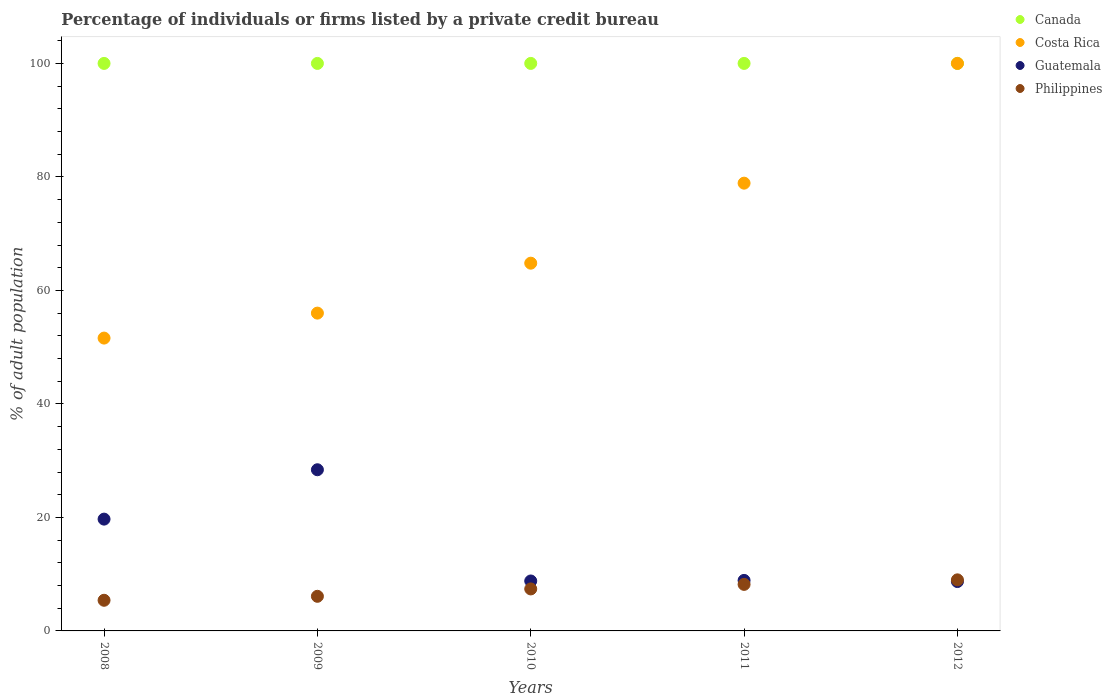What is the percentage of population listed by a private credit bureau in Canada in 2012?
Your answer should be very brief. 100. What is the total percentage of population listed by a private credit bureau in Guatemala in the graph?
Make the answer very short. 74.5. What is the difference between the percentage of population listed by a private credit bureau in Guatemala in 2011 and the percentage of population listed by a private credit bureau in Costa Rica in 2009?
Keep it short and to the point. -47.1. What is the average percentage of population listed by a private credit bureau in Philippines per year?
Give a very brief answer. 7.22. In the year 2011, what is the difference between the percentage of population listed by a private credit bureau in Costa Rica and percentage of population listed by a private credit bureau in Canada?
Provide a short and direct response. -21.1. In how many years, is the percentage of population listed by a private credit bureau in Costa Rica greater than 76 %?
Provide a short and direct response. 2. Is the percentage of population listed by a private credit bureau in Canada in 2008 less than that in 2011?
Your answer should be compact. No. Is the difference between the percentage of population listed by a private credit bureau in Costa Rica in 2008 and 2009 greater than the difference between the percentage of population listed by a private credit bureau in Canada in 2008 and 2009?
Your response must be concise. No. What is the difference between the highest and the second highest percentage of population listed by a private credit bureau in Costa Rica?
Give a very brief answer. 21.1. What is the difference between the highest and the lowest percentage of population listed by a private credit bureau in Costa Rica?
Offer a very short reply. 48.4. Is the sum of the percentage of population listed by a private credit bureau in Costa Rica in 2009 and 2012 greater than the maximum percentage of population listed by a private credit bureau in Guatemala across all years?
Give a very brief answer. Yes. Is it the case that in every year, the sum of the percentage of population listed by a private credit bureau in Costa Rica and percentage of population listed by a private credit bureau in Guatemala  is greater than the percentage of population listed by a private credit bureau in Philippines?
Provide a succinct answer. Yes. Does the percentage of population listed by a private credit bureau in Costa Rica monotonically increase over the years?
Keep it short and to the point. Yes. Is the percentage of population listed by a private credit bureau in Canada strictly greater than the percentage of population listed by a private credit bureau in Philippines over the years?
Provide a succinct answer. Yes. What is the difference between two consecutive major ticks on the Y-axis?
Provide a succinct answer. 20. Are the values on the major ticks of Y-axis written in scientific E-notation?
Your answer should be very brief. No. Does the graph contain grids?
Give a very brief answer. No. What is the title of the graph?
Offer a very short reply. Percentage of individuals or firms listed by a private credit bureau. What is the label or title of the X-axis?
Provide a short and direct response. Years. What is the label or title of the Y-axis?
Offer a terse response. % of adult population. What is the % of adult population in Costa Rica in 2008?
Provide a short and direct response. 51.6. What is the % of adult population in Guatemala in 2008?
Offer a terse response. 19.7. What is the % of adult population in Canada in 2009?
Your answer should be compact. 100. What is the % of adult population of Guatemala in 2009?
Make the answer very short. 28.4. What is the % of adult population of Philippines in 2009?
Give a very brief answer. 6.1. What is the % of adult population in Costa Rica in 2010?
Offer a terse response. 64.8. What is the % of adult population of Costa Rica in 2011?
Give a very brief answer. 78.9. What is the % of adult population in Canada in 2012?
Give a very brief answer. 100. What is the % of adult population of Guatemala in 2012?
Provide a succinct answer. 8.7. Across all years, what is the maximum % of adult population in Canada?
Offer a very short reply. 100. Across all years, what is the maximum % of adult population in Guatemala?
Offer a terse response. 28.4. Across all years, what is the maximum % of adult population in Philippines?
Your response must be concise. 9. Across all years, what is the minimum % of adult population of Costa Rica?
Your answer should be very brief. 51.6. Across all years, what is the minimum % of adult population in Philippines?
Provide a succinct answer. 5.4. What is the total % of adult population in Costa Rica in the graph?
Give a very brief answer. 351.3. What is the total % of adult population in Guatemala in the graph?
Offer a terse response. 74.5. What is the total % of adult population in Philippines in the graph?
Your answer should be compact. 36.1. What is the difference between the % of adult population of Canada in 2008 and that in 2010?
Give a very brief answer. 0. What is the difference between the % of adult population of Costa Rica in 2008 and that in 2010?
Offer a terse response. -13.2. What is the difference between the % of adult population in Philippines in 2008 and that in 2010?
Make the answer very short. -2. What is the difference between the % of adult population of Costa Rica in 2008 and that in 2011?
Provide a succinct answer. -27.3. What is the difference between the % of adult population of Canada in 2008 and that in 2012?
Your response must be concise. 0. What is the difference between the % of adult population of Costa Rica in 2008 and that in 2012?
Offer a terse response. -48.4. What is the difference between the % of adult population of Guatemala in 2008 and that in 2012?
Offer a terse response. 11. What is the difference between the % of adult population in Canada in 2009 and that in 2010?
Provide a succinct answer. 0. What is the difference between the % of adult population in Costa Rica in 2009 and that in 2010?
Make the answer very short. -8.8. What is the difference between the % of adult population of Guatemala in 2009 and that in 2010?
Your answer should be very brief. 19.6. What is the difference between the % of adult population of Philippines in 2009 and that in 2010?
Your response must be concise. -1.3. What is the difference between the % of adult population in Canada in 2009 and that in 2011?
Provide a short and direct response. 0. What is the difference between the % of adult population in Costa Rica in 2009 and that in 2011?
Your response must be concise. -22.9. What is the difference between the % of adult population in Guatemala in 2009 and that in 2011?
Provide a succinct answer. 19.5. What is the difference between the % of adult population of Canada in 2009 and that in 2012?
Provide a succinct answer. 0. What is the difference between the % of adult population in Costa Rica in 2009 and that in 2012?
Your response must be concise. -44. What is the difference between the % of adult population of Canada in 2010 and that in 2011?
Keep it short and to the point. 0. What is the difference between the % of adult population of Costa Rica in 2010 and that in 2011?
Keep it short and to the point. -14.1. What is the difference between the % of adult population in Philippines in 2010 and that in 2011?
Offer a very short reply. -0.8. What is the difference between the % of adult population in Canada in 2010 and that in 2012?
Your answer should be very brief. 0. What is the difference between the % of adult population of Costa Rica in 2010 and that in 2012?
Your response must be concise. -35.2. What is the difference between the % of adult population in Canada in 2011 and that in 2012?
Ensure brevity in your answer.  0. What is the difference between the % of adult population of Costa Rica in 2011 and that in 2012?
Your answer should be very brief. -21.1. What is the difference between the % of adult population in Guatemala in 2011 and that in 2012?
Keep it short and to the point. 0.2. What is the difference between the % of adult population of Canada in 2008 and the % of adult population of Guatemala in 2009?
Offer a terse response. 71.6. What is the difference between the % of adult population of Canada in 2008 and the % of adult population of Philippines in 2009?
Ensure brevity in your answer.  93.9. What is the difference between the % of adult population of Costa Rica in 2008 and the % of adult population of Guatemala in 2009?
Your answer should be very brief. 23.2. What is the difference between the % of adult population in Costa Rica in 2008 and the % of adult population in Philippines in 2009?
Provide a short and direct response. 45.5. What is the difference between the % of adult population in Canada in 2008 and the % of adult population in Costa Rica in 2010?
Give a very brief answer. 35.2. What is the difference between the % of adult population in Canada in 2008 and the % of adult population in Guatemala in 2010?
Your response must be concise. 91.2. What is the difference between the % of adult population in Canada in 2008 and the % of adult population in Philippines in 2010?
Make the answer very short. 92.6. What is the difference between the % of adult population in Costa Rica in 2008 and the % of adult population in Guatemala in 2010?
Offer a terse response. 42.8. What is the difference between the % of adult population in Costa Rica in 2008 and the % of adult population in Philippines in 2010?
Keep it short and to the point. 44.2. What is the difference between the % of adult population of Canada in 2008 and the % of adult population of Costa Rica in 2011?
Offer a terse response. 21.1. What is the difference between the % of adult population in Canada in 2008 and the % of adult population in Guatemala in 2011?
Ensure brevity in your answer.  91.1. What is the difference between the % of adult population of Canada in 2008 and the % of adult population of Philippines in 2011?
Keep it short and to the point. 91.8. What is the difference between the % of adult population of Costa Rica in 2008 and the % of adult population of Guatemala in 2011?
Give a very brief answer. 42.7. What is the difference between the % of adult population of Costa Rica in 2008 and the % of adult population of Philippines in 2011?
Ensure brevity in your answer.  43.4. What is the difference between the % of adult population of Canada in 2008 and the % of adult population of Guatemala in 2012?
Offer a terse response. 91.3. What is the difference between the % of adult population of Canada in 2008 and the % of adult population of Philippines in 2012?
Your answer should be compact. 91. What is the difference between the % of adult population of Costa Rica in 2008 and the % of adult population of Guatemala in 2012?
Your response must be concise. 42.9. What is the difference between the % of adult population in Costa Rica in 2008 and the % of adult population in Philippines in 2012?
Provide a succinct answer. 42.6. What is the difference between the % of adult population in Guatemala in 2008 and the % of adult population in Philippines in 2012?
Offer a very short reply. 10.7. What is the difference between the % of adult population of Canada in 2009 and the % of adult population of Costa Rica in 2010?
Your answer should be compact. 35.2. What is the difference between the % of adult population of Canada in 2009 and the % of adult population of Guatemala in 2010?
Ensure brevity in your answer.  91.2. What is the difference between the % of adult population of Canada in 2009 and the % of adult population of Philippines in 2010?
Keep it short and to the point. 92.6. What is the difference between the % of adult population of Costa Rica in 2009 and the % of adult population of Guatemala in 2010?
Your answer should be compact. 47.2. What is the difference between the % of adult population of Costa Rica in 2009 and the % of adult population of Philippines in 2010?
Your answer should be very brief. 48.6. What is the difference between the % of adult population of Canada in 2009 and the % of adult population of Costa Rica in 2011?
Offer a very short reply. 21.1. What is the difference between the % of adult population of Canada in 2009 and the % of adult population of Guatemala in 2011?
Your answer should be compact. 91.1. What is the difference between the % of adult population of Canada in 2009 and the % of adult population of Philippines in 2011?
Provide a short and direct response. 91.8. What is the difference between the % of adult population of Costa Rica in 2009 and the % of adult population of Guatemala in 2011?
Your answer should be compact. 47.1. What is the difference between the % of adult population in Costa Rica in 2009 and the % of adult population in Philippines in 2011?
Offer a very short reply. 47.8. What is the difference between the % of adult population of Guatemala in 2009 and the % of adult population of Philippines in 2011?
Your response must be concise. 20.2. What is the difference between the % of adult population in Canada in 2009 and the % of adult population in Guatemala in 2012?
Offer a very short reply. 91.3. What is the difference between the % of adult population in Canada in 2009 and the % of adult population in Philippines in 2012?
Give a very brief answer. 91. What is the difference between the % of adult population of Costa Rica in 2009 and the % of adult population of Guatemala in 2012?
Offer a very short reply. 47.3. What is the difference between the % of adult population of Canada in 2010 and the % of adult population of Costa Rica in 2011?
Make the answer very short. 21.1. What is the difference between the % of adult population in Canada in 2010 and the % of adult population in Guatemala in 2011?
Provide a succinct answer. 91.1. What is the difference between the % of adult population of Canada in 2010 and the % of adult population of Philippines in 2011?
Keep it short and to the point. 91.8. What is the difference between the % of adult population in Costa Rica in 2010 and the % of adult population in Guatemala in 2011?
Your response must be concise. 55.9. What is the difference between the % of adult population in Costa Rica in 2010 and the % of adult population in Philippines in 2011?
Give a very brief answer. 56.6. What is the difference between the % of adult population of Canada in 2010 and the % of adult population of Costa Rica in 2012?
Give a very brief answer. 0. What is the difference between the % of adult population of Canada in 2010 and the % of adult population of Guatemala in 2012?
Your response must be concise. 91.3. What is the difference between the % of adult population in Canada in 2010 and the % of adult population in Philippines in 2012?
Give a very brief answer. 91. What is the difference between the % of adult population of Costa Rica in 2010 and the % of adult population of Guatemala in 2012?
Make the answer very short. 56.1. What is the difference between the % of adult population of Costa Rica in 2010 and the % of adult population of Philippines in 2012?
Offer a terse response. 55.8. What is the difference between the % of adult population in Guatemala in 2010 and the % of adult population in Philippines in 2012?
Offer a very short reply. -0.2. What is the difference between the % of adult population in Canada in 2011 and the % of adult population in Guatemala in 2012?
Your response must be concise. 91.3. What is the difference between the % of adult population in Canada in 2011 and the % of adult population in Philippines in 2012?
Make the answer very short. 91. What is the difference between the % of adult population in Costa Rica in 2011 and the % of adult population in Guatemala in 2012?
Ensure brevity in your answer.  70.2. What is the difference between the % of adult population of Costa Rica in 2011 and the % of adult population of Philippines in 2012?
Offer a terse response. 69.9. What is the difference between the % of adult population in Guatemala in 2011 and the % of adult population in Philippines in 2012?
Your response must be concise. -0.1. What is the average % of adult population of Costa Rica per year?
Make the answer very short. 70.26. What is the average % of adult population in Guatemala per year?
Keep it short and to the point. 14.9. What is the average % of adult population of Philippines per year?
Keep it short and to the point. 7.22. In the year 2008, what is the difference between the % of adult population of Canada and % of adult population of Costa Rica?
Give a very brief answer. 48.4. In the year 2008, what is the difference between the % of adult population in Canada and % of adult population in Guatemala?
Give a very brief answer. 80.3. In the year 2008, what is the difference between the % of adult population in Canada and % of adult population in Philippines?
Provide a succinct answer. 94.6. In the year 2008, what is the difference between the % of adult population of Costa Rica and % of adult population of Guatemala?
Give a very brief answer. 31.9. In the year 2008, what is the difference between the % of adult population in Costa Rica and % of adult population in Philippines?
Provide a short and direct response. 46.2. In the year 2008, what is the difference between the % of adult population in Guatemala and % of adult population in Philippines?
Your answer should be compact. 14.3. In the year 2009, what is the difference between the % of adult population in Canada and % of adult population in Costa Rica?
Offer a very short reply. 44. In the year 2009, what is the difference between the % of adult population of Canada and % of adult population of Guatemala?
Your response must be concise. 71.6. In the year 2009, what is the difference between the % of adult population of Canada and % of adult population of Philippines?
Make the answer very short. 93.9. In the year 2009, what is the difference between the % of adult population in Costa Rica and % of adult population in Guatemala?
Offer a terse response. 27.6. In the year 2009, what is the difference between the % of adult population in Costa Rica and % of adult population in Philippines?
Provide a succinct answer. 49.9. In the year 2009, what is the difference between the % of adult population in Guatemala and % of adult population in Philippines?
Keep it short and to the point. 22.3. In the year 2010, what is the difference between the % of adult population of Canada and % of adult population of Costa Rica?
Make the answer very short. 35.2. In the year 2010, what is the difference between the % of adult population in Canada and % of adult population in Guatemala?
Provide a short and direct response. 91.2. In the year 2010, what is the difference between the % of adult population of Canada and % of adult population of Philippines?
Your answer should be very brief. 92.6. In the year 2010, what is the difference between the % of adult population of Costa Rica and % of adult population of Guatemala?
Offer a very short reply. 56. In the year 2010, what is the difference between the % of adult population in Costa Rica and % of adult population in Philippines?
Provide a succinct answer. 57.4. In the year 2011, what is the difference between the % of adult population of Canada and % of adult population of Costa Rica?
Give a very brief answer. 21.1. In the year 2011, what is the difference between the % of adult population of Canada and % of adult population of Guatemala?
Make the answer very short. 91.1. In the year 2011, what is the difference between the % of adult population in Canada and % of adult population in Philippines?
Make the answer very short. 91.8. In the year 2011, what is the difference between the % of adult population of Costa Rica and % of adult population of Guatemala?
Make the answer very short. 70. In the year 2011, what is the difference between the % of adult population in Costa Rica and % of adult population in Philippines?
Offer a terse response. 70.7. In the year 2011, what is the difference between the % of adult population of Guatemala and % of adult population of Philippines?
Offer a terse response. 0.7. In the year 2012, what is the difference between the % of adult population of Canada and % of adult population of Costa Rica?
Offer a terse response. 0. In the year 2012, what is the difference between the % of adult population of Canada and % of adult population of Guatemala?
Your response must be concise. 91.3. In the year 2012, what is the difference between the % of adult population in Canada and % of adult population in Philippines?
Ensure brevity in your answer.  91. In the year 2012, what is the difference between the % of adult population of Costa Rica and % of adult population of Guatemala?
Your response must be concise. 91.3. In the year 2012, what is the difference between the % of adult population of Costa Rica and % of adult population of Philippines?
Offer a terse response. 91. In the year 2012, what is the difference between the % of adult population in Guatemala and % of adult population in Philippines?
Give a very brief answer. -0.3. What is the ratio of the % of adult population of Canada in 2008 to that in 2009?
Keep it short and to the point. 1. What is the ratio of the % of adult population of Costa Rica in 2008 to that in 2009?
Keep it short and to the point. 0.92. What is the ratio of the % of adult population of Guatemala in 2008 to that in 2009?
Offer a terse response. 0.69. What is the ratio of the % of adult population of Philippines in 2008 to that in 2009?
Offer a very short reply. 0.89. What is the ratio of the % of adult population in Costa Rica in 2008 to that in 2010?
Give a very brief answer. 0.8. What is the ratio of the % of adult population in Guatemala in 2008 to that in 2010?
Offer a very short reply. 2.24. What is the ratio of the % of adult population of Philippines in 2008 to that in 2010?
Make the answer very short. 0.73. What is the ratio of the % of adult population in Canada in 2008 to that in 2011?
Provide a succinct answer. 1. What is the ratio of the % of adult population of Costa Rica in 2008 to that in 2011?
Give a very brief answer. 0.65. What is the ratio of the % of adult population in Guatemala in 2008 to that in 2011?
Make the answer very short. 2.21. What is the ratio of the % of adult population of Philippines in 2008 to that in 2011?
Give a very brief answer. 0.66. What is the ratio of the % of adult population in Canada in 2008 to that in 2012?
Your answer should be very brief. 1. What is the ratio of the % of adult population of Costa Rica in 2008 to that in 2012?
Offer a very short reply. 0.52. What is the ratio of the % of adult population in Guatemala in 2008 to that in 2012?
Provide a short and direct response. 2.26. What is the ratio of the % of adult population of Philippines in 2008 to that in 2012?
Give a very brief answer. 0.6. What is the ratio of the % of adult population in Canada in 2009 to that in 2010?
Your answer should be compact. 1. What is the ratio of the % of adult population of Costa Rica in 2009 to that in 2010?
Keep it short and to the point. 0.86. What is the ratio of the % of adult population of Guatemala in 2009 to that in 2010?
Provide a succinct answer. 3.23. What is the ratio of the % of adult population in Philippines in 2009 to that in 2010?
Offer a very short reply. 0.82. What is the ratio of the % of adult population of Costa Rica in 2009 to that in 2011?
Offer a terse response. 0.71. What is the ratio of the % of adult population of Guatemala in 2009 to that in 2011?
Keep it short and to the point. 3.19. What is the ratio of the % of adult population of Philippines in 2009 to that in 2011?
Provide a short and direct response. 0.74. What is the ratio of the % of adult population in Canada in 2009 to that in 2012?
Make the answer very short. 1. What is the ratio of the % of adult population of Costa Rica in 2009 to that in 2012?
Keep it short and to the point. 0.56. What is the ratio of the % of adult population of Guatemala in 2009 to that in 2012?
Ensure brevity in your answer.  3.26. What is the ratio of the % of adult population of Philippines in 2009 to that in 2012?
Give a very brief answer. 0.68. What is the ratio of the % of adult population of Canada in 2010 to that in 2011?
Your response must be concise. 1. What is the ratio of the % of adult population of Costa Rica in 2010 to that in 2011?
Make the answer very short. 0.82. What is the ratio of the % of adult population of Guatemala in 2010 to that in 2011?
Ensure brevity in your answer.  0.99. What is the ratio of the % of adult population of Philippines in 2010 to that in 2011?
Provide a succinct answer. 0.9. What is the ratio of the % of adult population of Costa Rica in 2010 to that in 2012?
Your response must be concise. 0.65. What is the ratio of the % of adult population in Guatemala in 2010 to that in 2012?
Make the answer very short. 1.01. What is the ratio of the % of adult population of Philippines in 2010 to that in 2012?
Give a very brief answer. 0.82. What is the ratio of the % of adult population in Costa Rica in 2011 to that in 2012?
Provide a succinct answer. 0.79. What is the ratio of the % of adult population of Guatemala in 2011 to that in 2012?
Your answer should be compact. 1.02. What is the ratio of the % of adult population in Philippines in 2011 to that in 2012?
Provide a succinct answer. 0.91. What is the difference between the highest and the second highest % of adult population of Canada?
Offer a terse response. 0. What is the difference between the highest and the second highest % of adult population of Costa Rica?
Ensure brevity in your answer.  21.1. What is the difference between the highest and the lowest % of adult population in Costa Rica?
Provide a short and direct response. 48.4. 